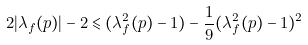<formula> <loc_0><loc_0><loc_500><loc_500>2 | \lambda _ { f } ( p ) | - 2 \leqslant ( \lambda _ { f } ^ { 2 } ( p ) - 1 ) - \frac { 1 } { 9 } ( \lambda _ { f } ^ { 2 } ( p ) - 1 ) ^ { 2 }</formula> 